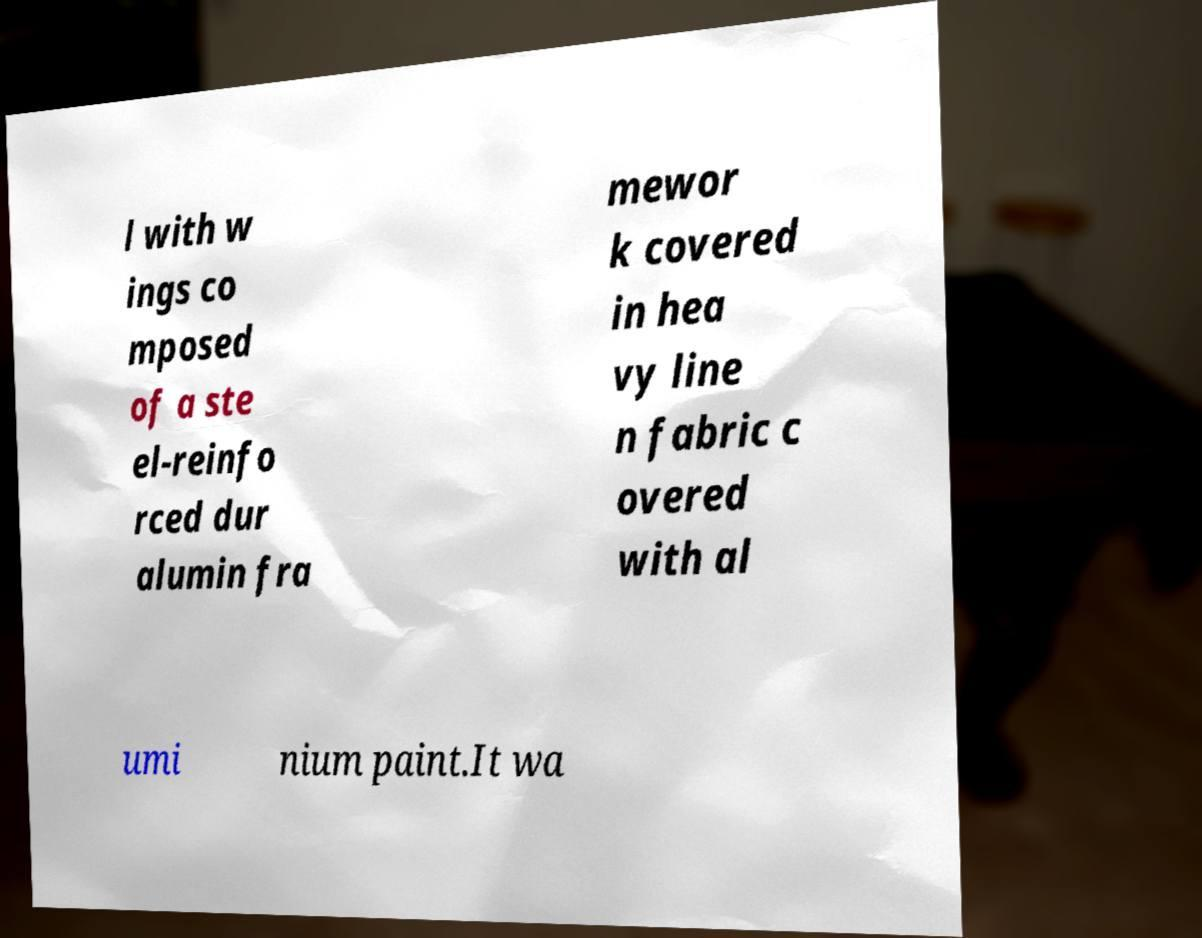There's text embedded in this image that I need extracted. Can you transcribe it verbatim? l with w ings co mposed of a ste el-reinfo rced dur alumin fra mewor k covered in hea vy line n fabric c overed with al umi nium paint.It wa 